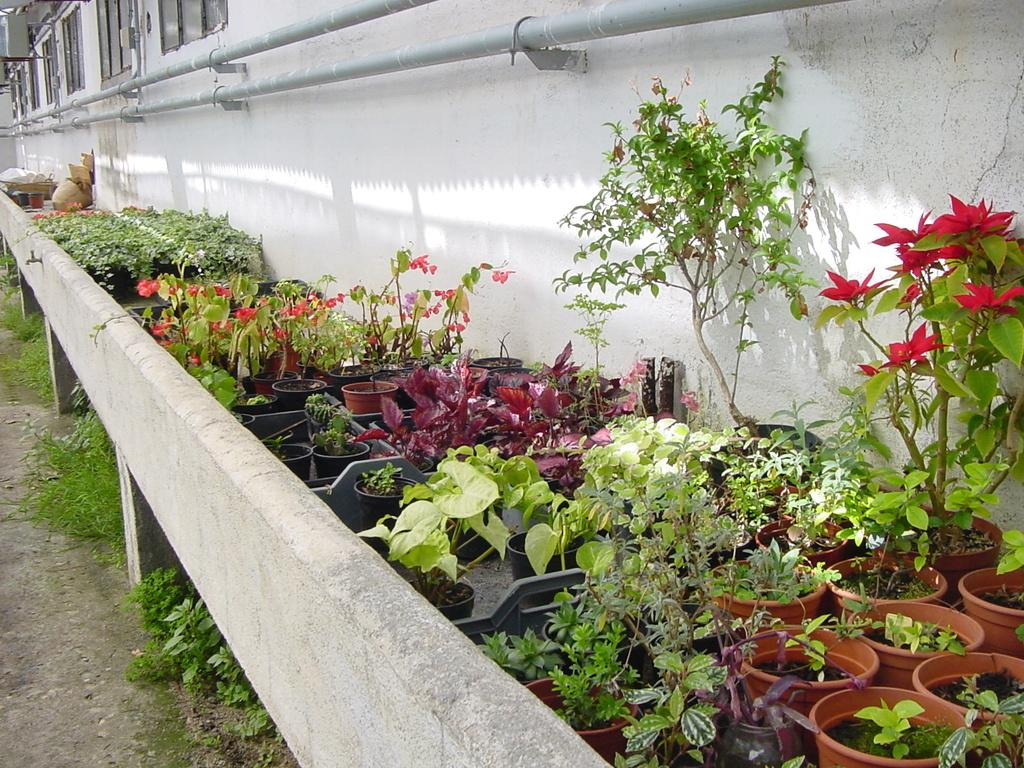What objects are arranged in a series in the image? There are flower pots arranged in a series in the image. What can be seen at the top side of the image? There are pipes at the top side of the image. Where are the windows located in the image? The windows are in the top left side of the image. Reasoning: Let'g: Let's think step by step in order to produce the conversation. We start by identifying the main subject in the image, which is the flower pots arranged in a series. Then, we expand the conversation to include other objects that are also visible, such as the pipes and windows. Each question is designed to elicit a specific detail about the image that is known from the provided facts. Absurd Question/Answer: How many visitors are present in the image? There is no indication of any visitors in the image. Which direction is north in the image? The image does not provide any information about the direction of north. 